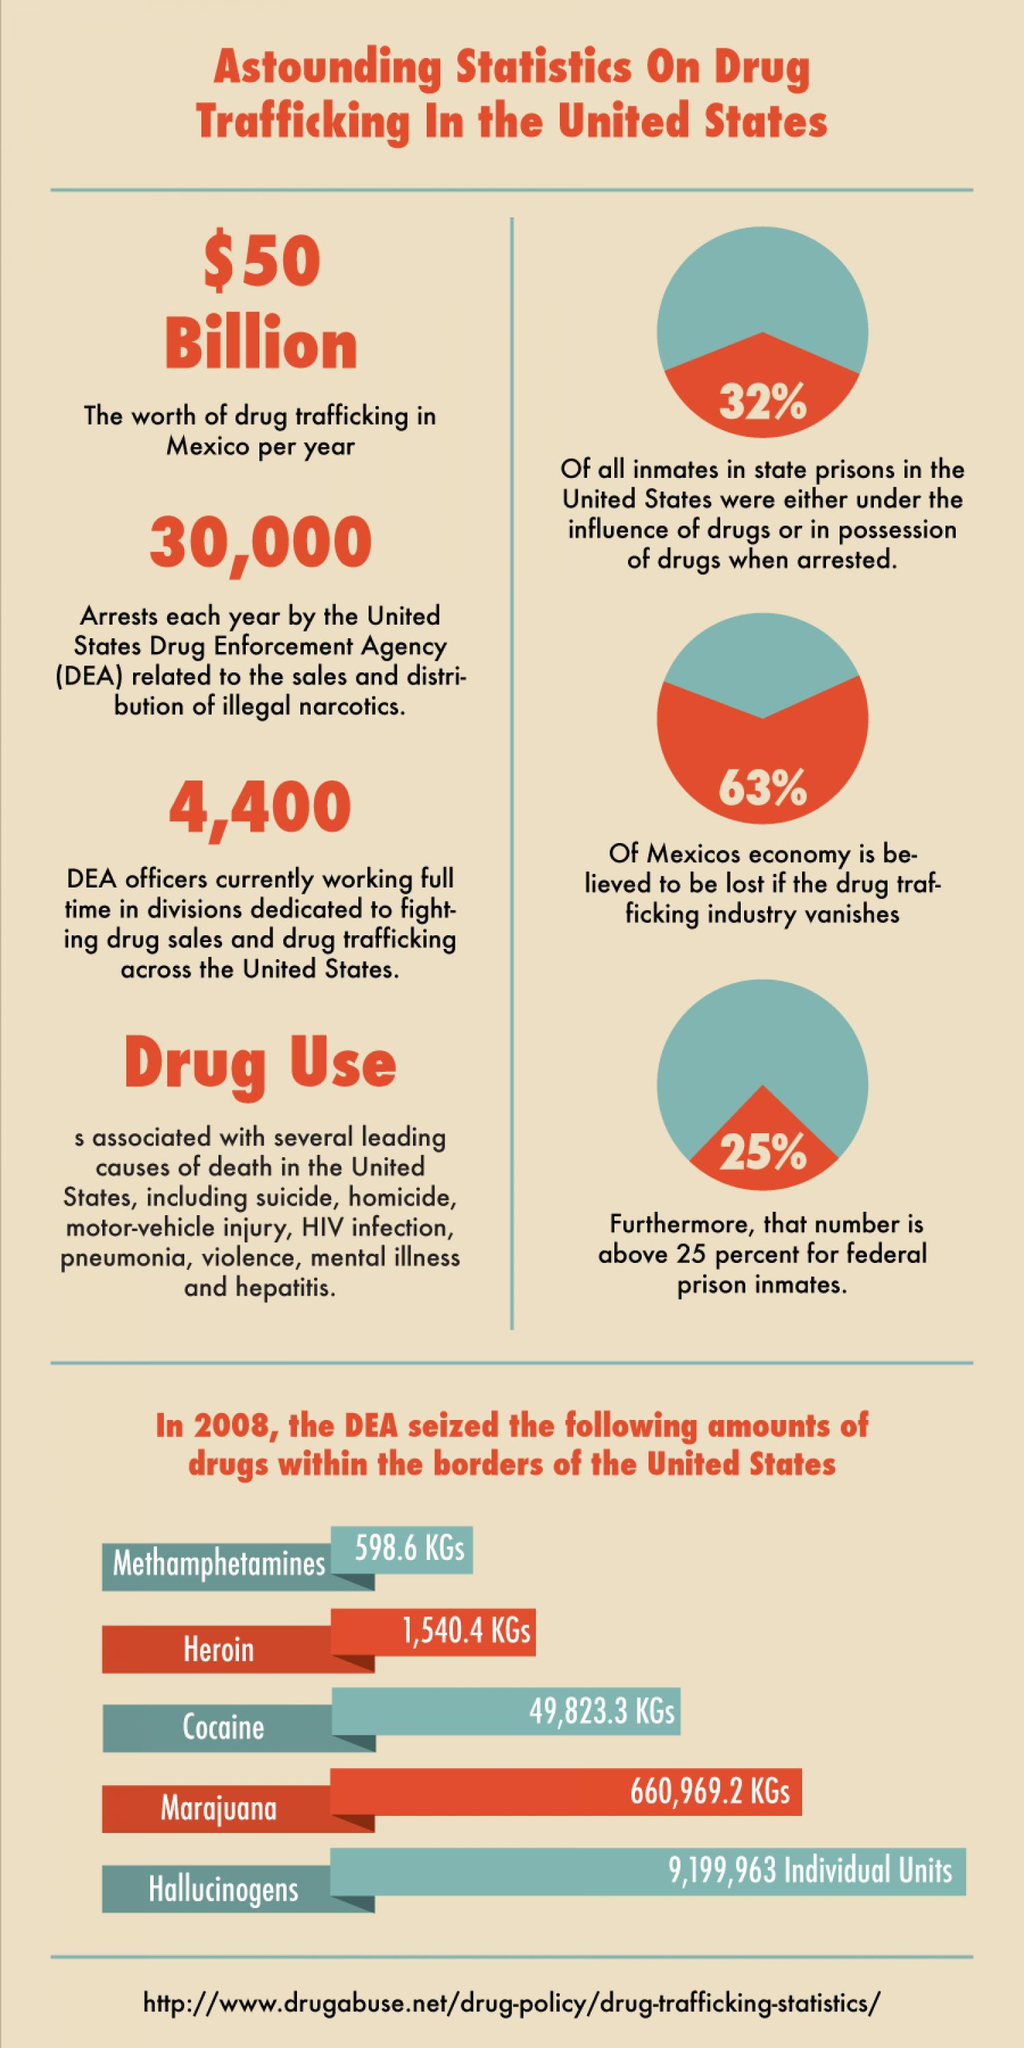List a handful of essential elements in this visual. The worth of drug trafficking in Mexico is estimated to be approximately $50 billion per year. In the United States, the Drug Enforcement Agency makes approximately 30,000 arrests annually for drug-related offenses, including the sale and distribution of illegal narcotics. In 2008, a total of 1,540.4 kilograms of Heroin was seized within the borders of the United States. 